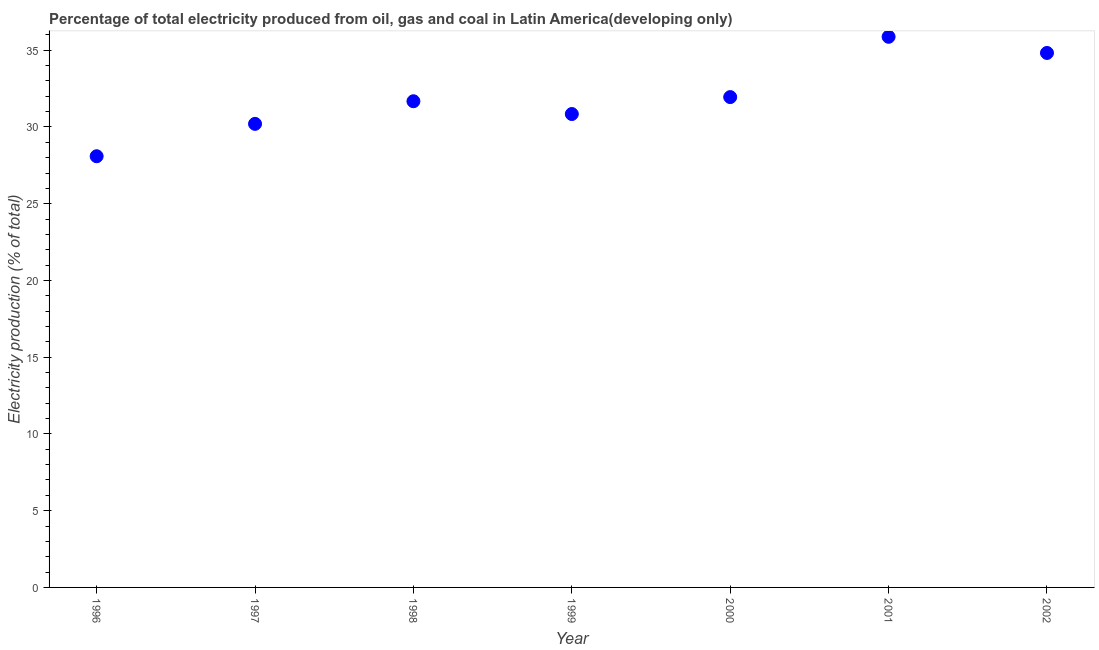What is the electricity production in 2000?
Your answer should be very brief. 31.95. Across all years, what is the maximum electricity production?
Keep it short and to the point. 35.87. Across all years, what is the minimum electricity production?
Ensure brevity in your answer.  28.09. In which year was the electricity production minimum?
Offer a terse response. 1996. What is the sum of the electricity production?
Ensure brevity in your answer.  223.45. What is the difference between the electricity production in 1996 and 2000?
Your response must be concise. -3.85. What is the average electricity production per year?
Give a very brief answer. 31.92. What is the median electricity production?
Your answer should be very brief. 31.68. In how many years, is the electricity production greater than 31 %?
Ensure brevity in your answer.  4. What is the ratio of the electricity production in 1997 to that in 2001?
Offer a very short reply. 0.84. Is the difference between the electricity production in 2000 and 2002 greater than the difference between any two years?
Offer a very short reply. No. What is the difference between the highest and the second highest electricity production?
Provide a succinct answer. 1.05. Is the sum of the electricity production in 1999 and 2002 greater than the maximum electricity production across all years?
Keep it short and to the point. Yes. What is the difference between the highest and the lowest electricity production?
Offer a terse response. 7.78. In how many years, is the electricity production greater than the average electricity production taken over all years?
Provide a short and direct response. 3. Are the values on the major ticks of Y-axis written in scientific E-notation?
Give a very brief answer. No. Does the graph contain any zero values?
Make the answer very short. No. Does the graph contain grids?
Make the answer very short. No. What is the title of the graph?
Offer a very short reply. Percentage of total electricity produced from oil, gas and coal in Latin America(developing only). What is the label or title of the Y-axis?
Provide a succinct answer. Electricity production (% of total). What is the Electricity production (% of total) in 1996?
Make the answer very short. 28.09. What is the Electricity production (% of total) in 1997?
Your response must be concise. 30.2. What is the Electricity production (% of total) in 1998?
Your answer should be compact. 31.68. What is the Electricity production (% of total) in 1999?
Offer a terse response. 30.84. What is the Electricity production (% of total) in 2000?
Provide a succinct answer. 31.95. What is the Electricity production (% of total) in 2001?
Keep it short and to the point. 35.87. What is the Electricity production (% of total) in 2002?
Your response must be concise. 34.82. What is the difference between the Electricity production (% of total) in 1996 and 1997?
Offer a terse response. -2.11. What is the difference between the Electricity production (% of total) in 1996 and 1998?
Your response must be concise. -3.58. What is the difference between the Electricity production (% of total) in 1996 and 1999?
Your answer should be very brief. -2.75. What is the difference between the Electricity production (% of total) in 1996 and 2000?
Your response must be concise. -3.85. What is the difference between the Electricity production (% of total) in 1996 and 2001?
Provide a succinct answer. -7.78. What is the difference between the Electricity production (% of total) in 1996 and 2002?
Keep it short and to the point. -6.73. What is the difference between the Electricity production (% of total) in 1997 and 1998?
Make the answer very short. -1.47. What is the difference between the Electricity production (% of total) in 1997 and 1999?
Offer a very short reply. -0.64. What is the difference between the Electricity production (% of total) in 1997 and 2000?
Keep it short and to the point. -1.74. What is the difference between the Electricity production (% of total) in 1997 and 2001?
Provide a succinct answer. -5.67. What is the difference between the Electricity production (% of total) in 1997 and 2002?
Offer a terse response. -4.62. What is the difference between the Electricity production (% of total) in 1998 and 1999?
Provide a succinct answer. 0.83. What is the difference between the Electricity production (% of total) in 1998 and 2000?
Your answer should be very brief. -0.27. What is the difference between the Electricity production (% of total) in 1998 and 2001?
Provide a short and direct response. -4.2. What is the difference between the Electricity production (% of total) in 1998 and 2002?
Provide a succinct answer. -3.15. What is the difference between the Electricity production (% of total) in 1999 and 2000?
Your response must be concise. -1.1. What is the difference between the Electricity production (% of total) in 1999 and 2001?
Provide a succinct answer. -5.03. What is the difference between the Electricity production (% of total) in 1999 and 2002?
Keep it short and to the point. -3.98. What is the difference between the Electricity production (% of total) in 2000 and 2001?
Provide a short and direct response. -3.93. What is the difference between the Electricity production (% of total) in 2000 and 2002?
Your answer should be compact. -2.88. What is the difference between the Electricity production (% of total) in 2001 and 2002?
Ensure brevity in your answer.  1.05. What is the ratio of the Electricity production (% of total) in 1996 to that in 1998?
Your answer should be very brief. 0.89. What is the ratio of the Electricity production (% of total) in 1996 to that in 1999?
Your answer should be very brief. 0.91. What is the ratio of the Electricity production (% of total) in 1996 to that in 2000?
Your response must be concise. 0.88. What is the ratio of the Electricity production (% of total) in 1996 to that in 2001?
Provide a succinct answer. 0.78. What is the ratio of the Electricity production (% of total) in 1996 to that in 2002?
Give a very brief answer. 0.81. What is the ratio of the Electricity production (% of total) in 1997 to that in 1998?
Your answer should be very brief. 0.95. What is the ratio of the Electricity production (% of total) in 1997 to that in 1999?
Offer a terse response. 0.98. What is the ratio of the Electricity production (% of total) in 1997 to that in 2000?
Offer a very short reply. 0.94. What is the ratio of the Electricity production (% of total) in 1997 to that in 2001?
Give a very brief answer. 0.84. What is the ratio of the Electricity production (% of total) in 1997 to that in 2002?
Give a very brief answer. 0.87. What is the ratio of the Electricity production (% of total) in 1998 to that in 1999?
Give a very brief answer. 1.03. What is the ratio of the Electricity production (% of total) in 1998 to that in 2000?
Your answer should be very brief. 0.99. What is the ratio of the Electricity production (% of total) in 1998 to that in 2001?
Offer a very short reply. 0.88. What is the ratio of the Electricity production (% of total) in 1998 to that in 2002?
Ensure brevity in your answer.  0.91. What is the ratio of the Electricity production (% of total) in 1999 to that in 2000?
Keep it short and to the point. 0.96. What is the ratio of the Electricity production (% of total) in 1999 to that in 2001?
Provide a succinct answer. 0.86. What is the ratio of the Electricity production (% of total) in 1999 to that in 2002?
Ensure brevity in your answer.  0.89. What is the ratio of the Electricity production (% of total) in 2000 to that in 2001?
Ensure brevity in your answer.  0.89. What is the ratio of the Electricity production (% of total) in 2000 to that in 2002?
Ensure brevity in your answer.  0.92. 